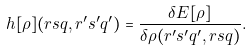Convert formula to latex. <formula><loc_0><loc_0><loc_500><loc_500>h [ \rho ] ( r s q , r ^ { \prime } s ^ { \prime } q ^ { \prime } ) = \frac { \delta E [ \rho ] } { \delta \rho ( r ^ { \prime } s ^ { \prime } q ^ { \prime } , r s q ) } .</formula> 